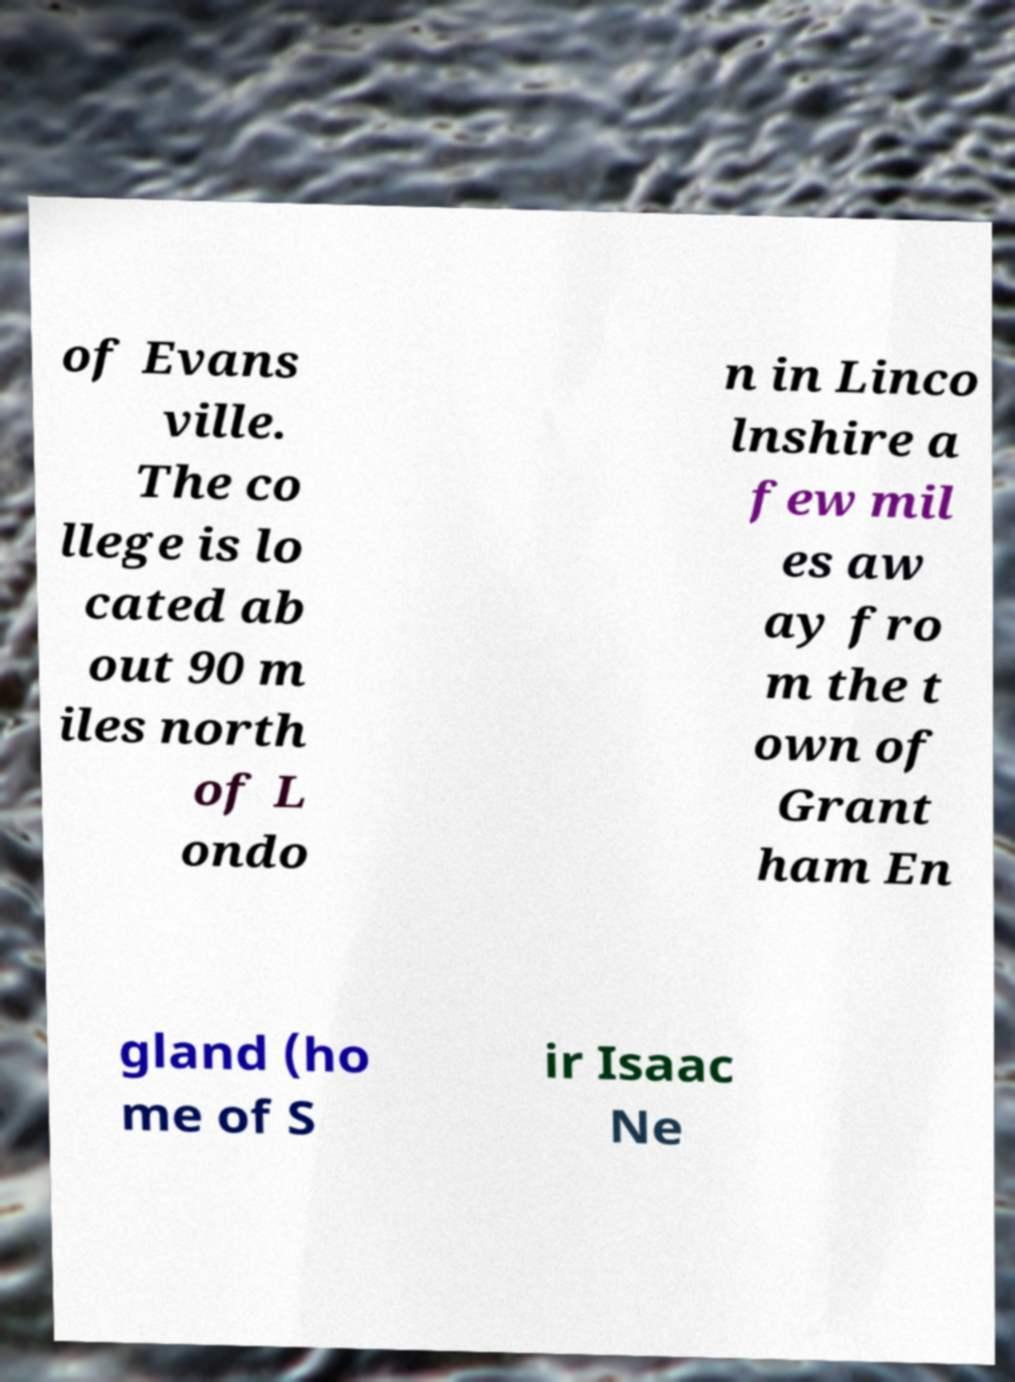Could you assist in decoding the text presented in this image and type it out clearly? of Evans ville. The co llege is lo cated ab out 90 m iles north of L ondo n in Linco lnshire a few mil es aw ay fro m the t own of Grant ham En gland (ho me of S ir Isaac Ne 